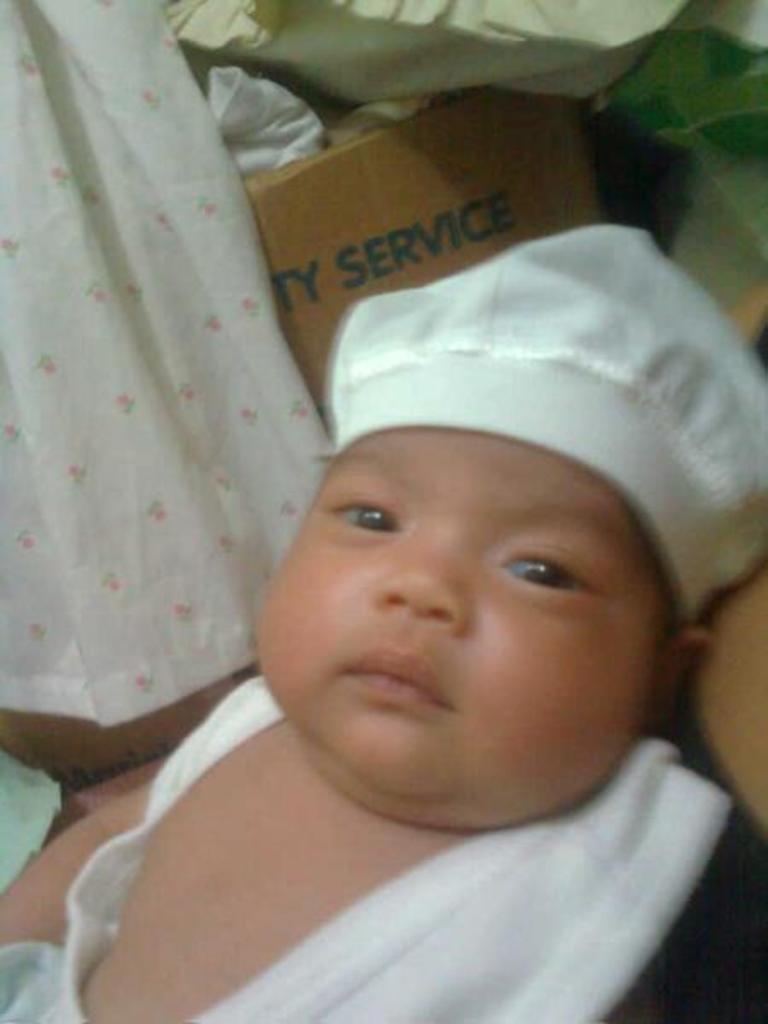In one or two sentences, can you explain what this image depicts? In this image there is a small kid with a white cap. On the left side top corner there is a white curtain. Beside the curtain there is a cardboard box. On the cardboard box there is a pillow. 